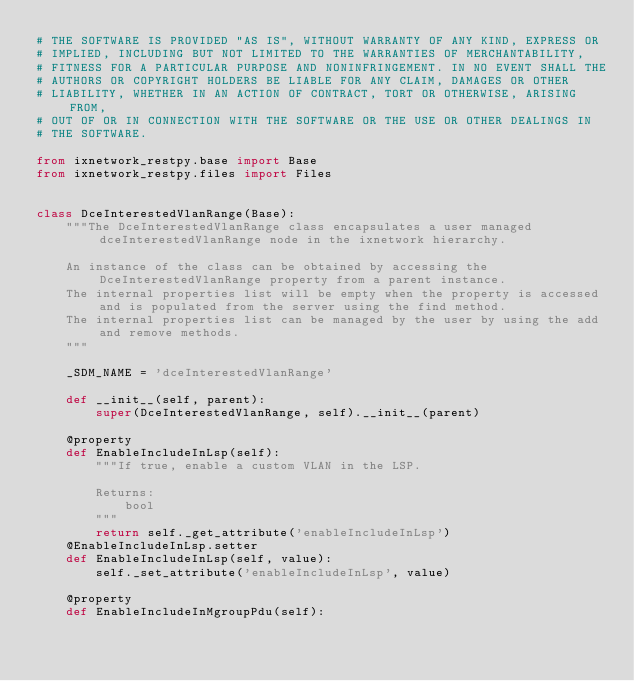<code> <loc_0><loc_0><loc_500><loc_500><_Python_># THE SOFTWARE IS PROVIDED "AS IS", WITHOUT WARRANTY OF ANY KIND, EXPRESS OR
# IMPLIED, INCLUDING BUT NOT LIMITED TO THE WARRANTIES OF MERCHANTABILITY,
# FITNESS FOR A PARTICULAR PURPOSE AND NONINFRINGEMENT. IN NO EVENT SHALL THE
# AUTHORS OR COPYRIGHT HOLDERS BE LIABLE FOR ANY CLAIM, DAMAGES OR OTHER
# LIABILITY, WHETHER IN AN ACTION OF CONTRACT, TORT OR OTHERWISE, ARISING FROM,
# OUT OF OR IN CONNECTION WITH THE SOFTWARE OR THE USE OR OTHER DEALINGS IN
# THE SOFTWARE.
    
from ixnetwork_restpy.base import Base
from ixnetwork_restpy.files import Files


class DceInterestedVlanRange(Base):
	"""The DceInterestedVlanRange class encapsulates a user managed dceInterestedVlanRange node in the ixnetwork hierarchy.

	An instance of the class can be obtained by accessing the DceInterestedVlanRange property from a parent instance.
	The internal properties list will be empty when the property is accessed and is populated from the server using the find method.
	The internal properties list can be managed by the user by using the add and remove methods.
	"""

	_SDM_NAME = 'dceInterestedVlanRange'

	def __init__(self, parent):
		super(DceInterestedVlanRange, self).__init__(parent)

	@property
	def EnableIncludeInLsp(self):
		"""If true, enable a custom VLAN in the LSP.

		Returns:
			bool
		"""
		return self._get_attribute('enableIncludeInLsp')
	@EnableIncludeInLsp.setter
	def EnableIncludeInLsp(self, value):
		self._set_attribute('enableIncludeInLsp', value)

	@property
	def EnableIncludeInMgroupPdu(self):</code> 